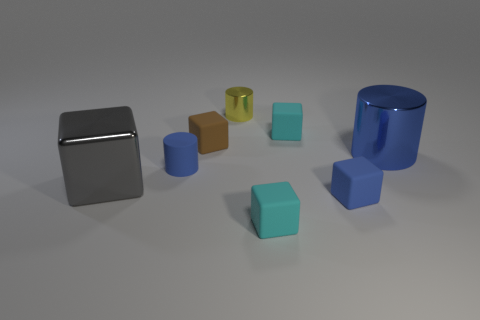Add 1 gray balls. How many objects exist? 9 Subtract all tiny brown cubes. How many cubes are left? 4 Subtract all gray blocks. How many blocks are left? 4 Subtract 4 cubes. How many cubes are left? 1 Subtract all purple cubes. How many blue cylinders are left? 2 Add 1 tiny yellow things. How many tiny yellow things are left? 2 Add 3 yellow matte blocks. How many yellow matte blocks exist? 3 Subtract 1 cyan blocks. How many objects are left? 7 Subtract all cubes. How many objects are left? 3 Subtract all red cylinders. Subtract all yellow blocks. How many cylinders are left? 3 